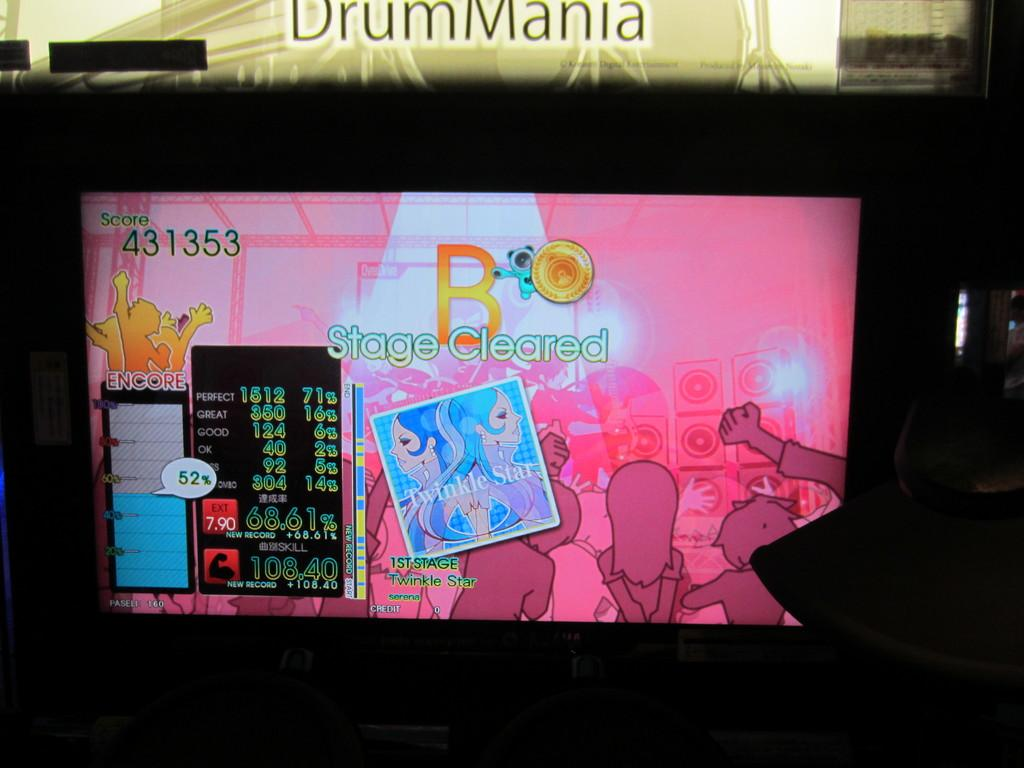<image>
Relay a brief, clear account of the picture shown. The current score on the board is 431353 